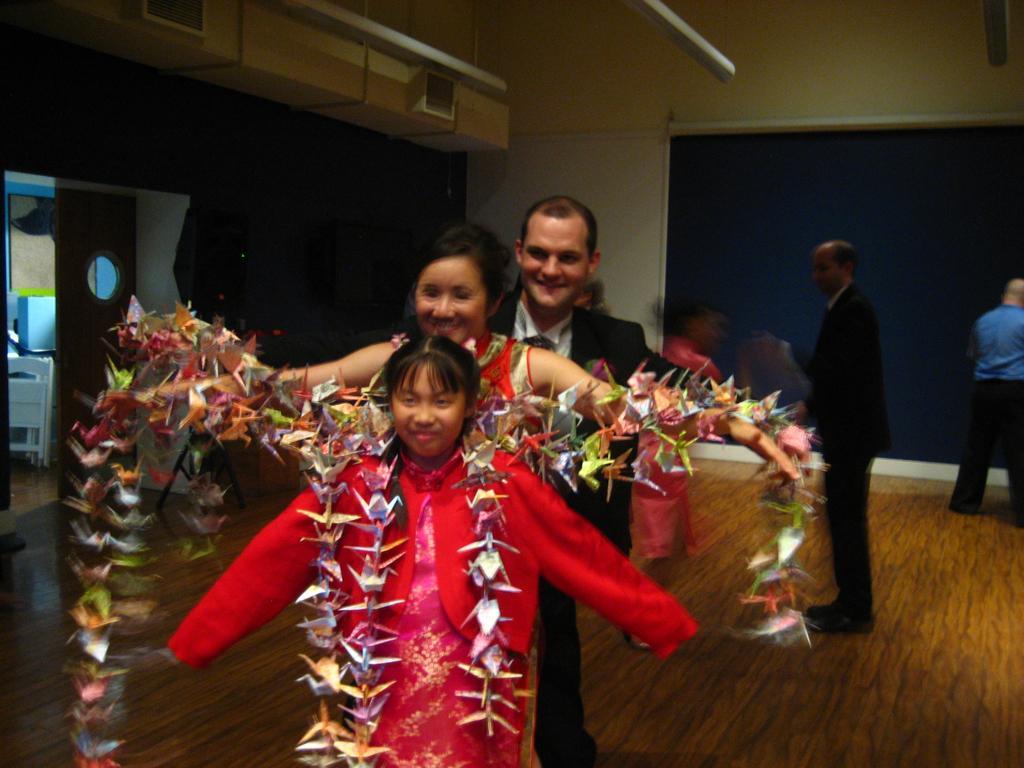How would you summarize this image in a sentence or two? In the center of the image we can see persons standing on the floor. In the background we can see door, screen, air conditioner and wall. 